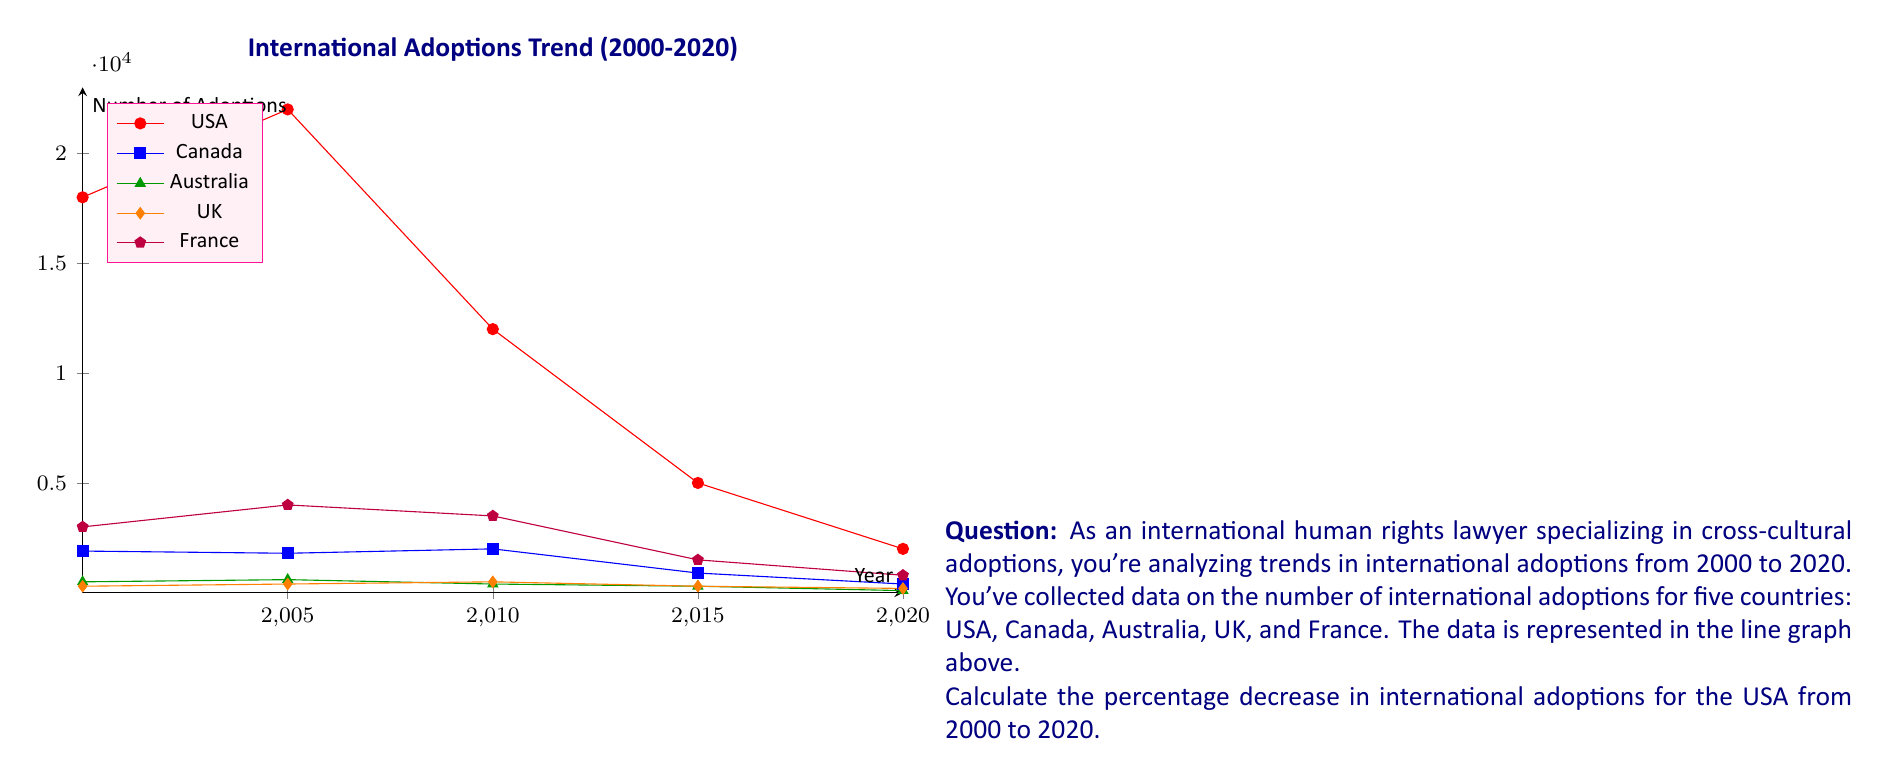Give your solution to this math problem. To calculate the percentage decrease in international adoptions for the USA from 2000 to 2020, we need to follow these steps:

1. Identify the number of adoptions in 2000 and 2020:
   2000: 18,000 adoptions
   2020: 2,000 adoptions

2. Calculate the decrease in adoptions:
   $\text{Decrease} = 18,000 - 2,000 = 16,000$

3. Calculate the percentage decrease using the formula:
   $$\text{Percentage Decrease} = \frac{\text{Decrease}}{\text{Original Value}} \times 100\%$$

4. Plug in the values:
   $$\text{Percentage Decrease} = \frac{16,000}{18,000} \times 100\%$$

5. Perform the calculation:
   $$\text{Percentage Decrease} = 0.8888... \times 100\% \approx 88.89\%$$

Therefore, the percentage decrease in international adoptions for the USA from 2000 to 2020 is approximately 88.89%.
Answer: 88.89% 